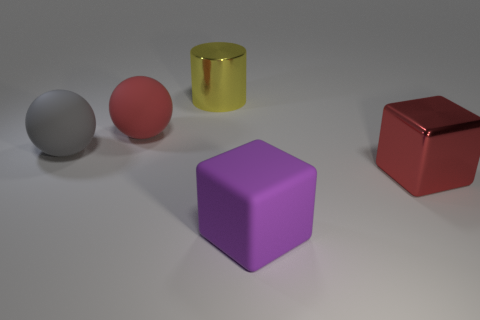Add 5 green metallic cylinders. How many objects exist? 10 Subtract all cubes. How many objects are left? 3 Subtract all large yellow things. Subtract all big cyan shiny cubes. How many objects are left? 4 Add 5 big red metallic cubes. How many big red metallic cubes are left? 6 Add 5 red cubes. How many red cubes exist? 6 Subtract 0 cyan cylinders. How many objects are left? 5 